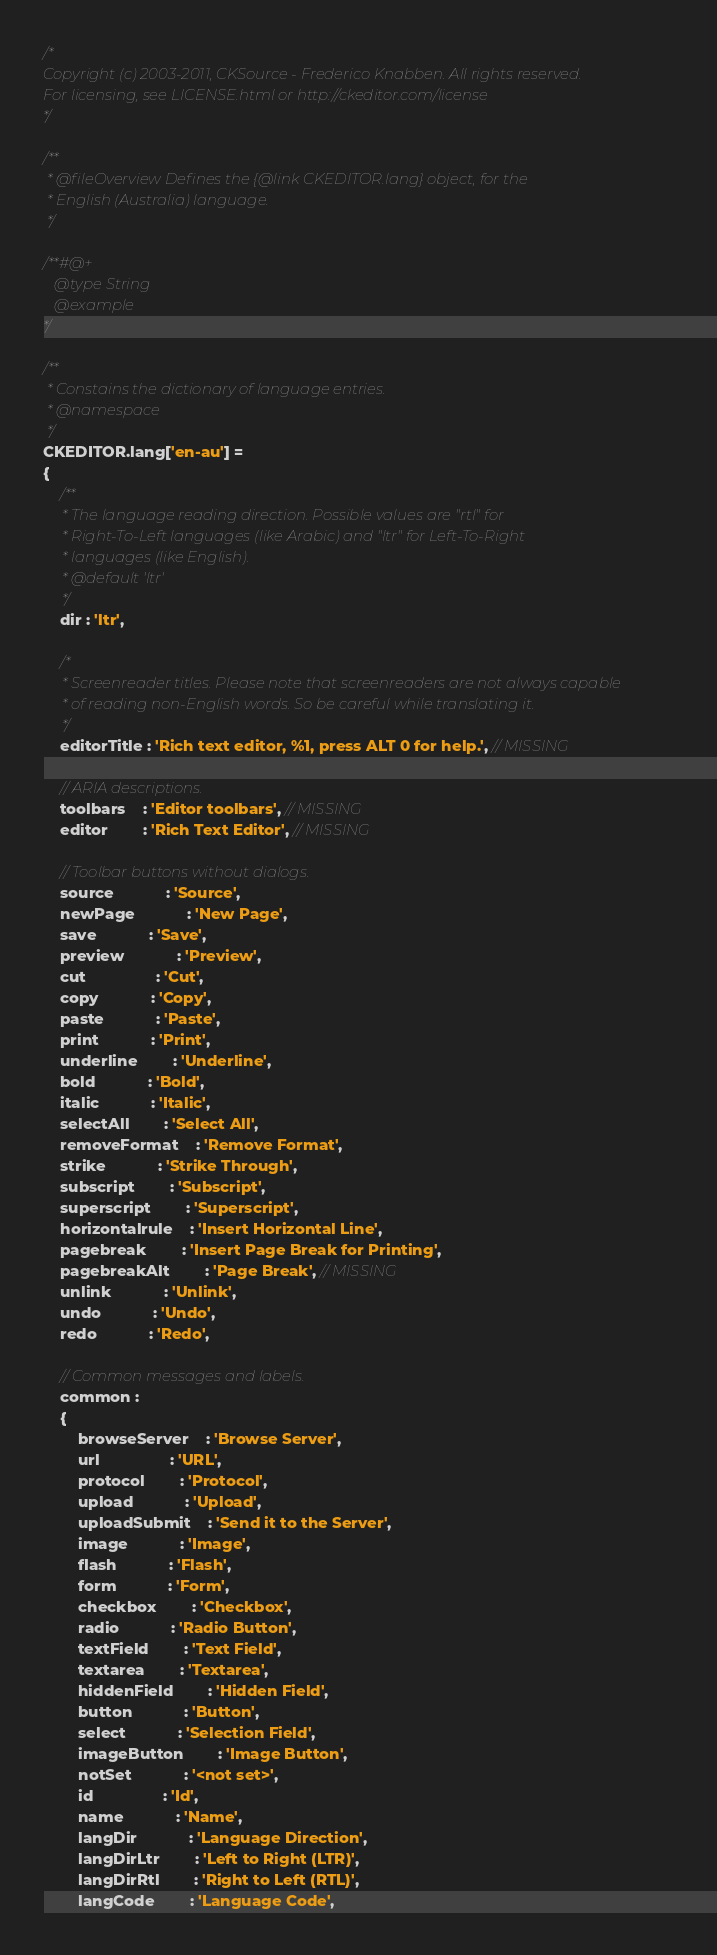Convert code to text. <code><loc_0><loc_0><loc_500><loc_500><_JavaScript_>/*
Copyright (c) 2003-2011, CKSource - Frederico Knabben. All rights reserved.
For licensing, see LICENSE.html or http://ckeditor.com/license
*/

/**
 * @fileOverview Defines the {@link CKEDITOR.lang} object, for the
 * English (Australia) language.
 */

/**#@+
   @type String
   @example
*/

/**
 * Constains the dictionary of language entries.
 * @namespace
 */
CKEDITOR.lang['en-au'] =
{
	/**
	 * The language reading direction. Possible values are "rtl" for
	 * Right-To-Left languages (like Arabic) and "ltr" for Left-To-Right
	 * languages (like English).
	 * @default 'ltr'
	 */
	dir : 'ltr',

	/*
	 * Screenreader titles. Please note that screenreaders are not always capable
	 * of reading non-English words. So be careful while translating it.
	 */
	editorTitle : 'Rich text editor, %1, press ALT 0 for help.', // MISSING

	// ARIA descriptions.
	toolbars	: 'Editor toolbars', // MISSING
	editor		: 'Rich Text Editor', // MISSING

	// Toolbar buttons without dialogs.
	source			: 'Source',
	newPage			: 'New Page',
	save			: 'Save',
	preview			: 'Preview',
	cut				: 'Cut',
	copy			: 'Copy',
	paste			: 'Paste',
	print			: 'Print',
	underline		: 'Underline',
	bold			: 'Bold',
	italic			: 'Italic',
	selectAll		: 'Select All',
	removeFormat	: 'Remove Format',
	strike			: 'Strike Through',
	subscript		: 'Subscript',
	superscript		: 'Superscript',
	horizontalrule	: 'Insert Horizontal Line',
	pagebreak		: 'Insert Page Break for Printing',
	pagebreakAlt		: 'Page Break', // MISSING
	unlink			: 'Unlink',
	undo			: 'Undo',
	redo			: 'Redo',

	// Common messages and labels.
	common :
	{
		browseServer	: 'Browse Server',
		url				: 'URL',
		protocol		: 'Protocol',
		upload			: 'Upload',
		uploadSubmit	: 'Send it to the Server',
		image			: 'Image',
		flash			: 'Flash',
		form			: 'Form',
		checkbox		: 'Checkbox',
		radio			: 'Radio Button',
		textField		: 'Text Field',
		textarea		: 'Textarea',
		hiddenField		: 'Hidden Field',
		button			: 'Button',
		select			: 'Selection Field',
		imageButton		: 'Image Button',
		notSet			: '<not set>',
		id				: 'Id',
		name			: 'Name',
		langDir			: 'Language Direction',
		langDirLtr		: 'Left to Right (LTR)',
		langDirRtl		: 'Right to Left (RTL)',
		langCode		: 'Language Code',</code> 